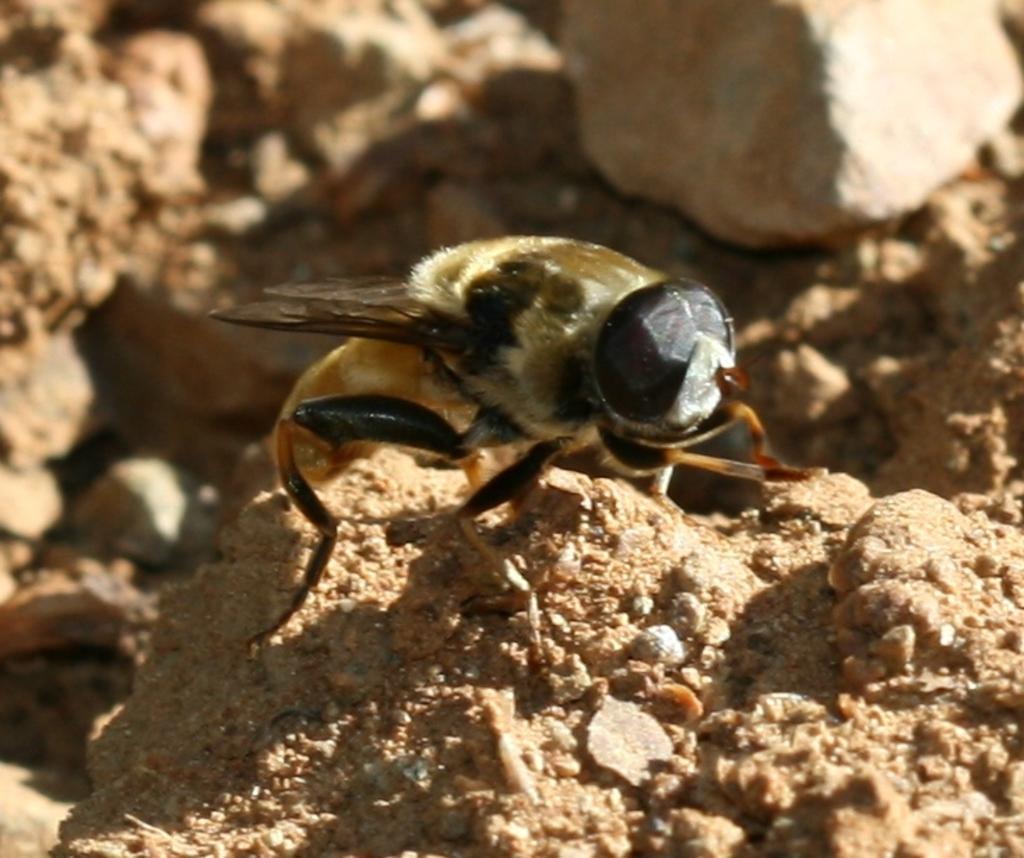Could you give a brief overview of what you see in this image? In this picture we can see an insect and in the background we can see stones. 